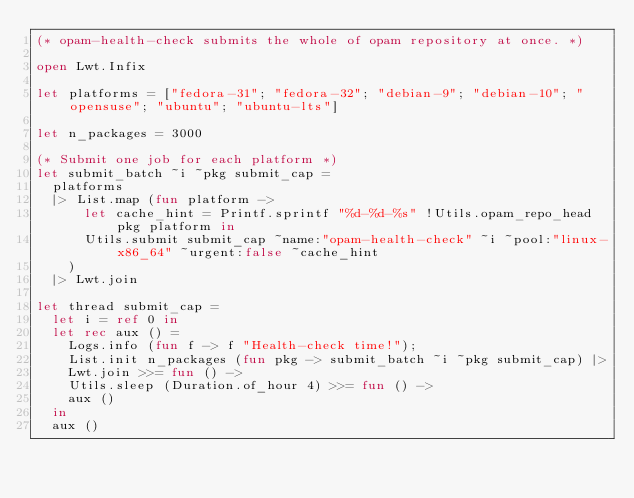Convert code to text. <code><loc_0><loc_0><loc_500><loc_500><_OCaml_>(* opam-health-check submits the whole of opam repository at once. *)

open Lwt.Infix

let platforms = ["fedora-31"; "fedora-32"; "debian-9"; "debian-10"; "opensuse"; "ubuntu"; "ubuntu-lts"]

let n_packages = 3000

(* Submit one job for each platform *)
let submit_batch ~i ~pkg submit_cap =
  platforms
  |> List.map (fun platform ->
      let cache_hint = Printf.sprintf "%d-%d-%s" !Utils.opam_repo_head pkg platform in
      Utils.submit submit_cap ~name:"opam-health-check" ~i ~pool:"linux-x86_64" ~urgent:false ~cache_hint
    )
  |> Lwt.join

let thread submit_cap =
  let i = ref 0 in
  let rec aux () =
    Logs.info (fun f -> f "Health-check time!");
    List.init n_packages (fun pkg -> submit_batch ~i ~pkg submit_cap) |>
    Lwt.join >>= fun () ->
    Utils.sleep (Duration.of_hour 4) >>= fun () ->
    aux ()
  in
  aux ()
</code> 